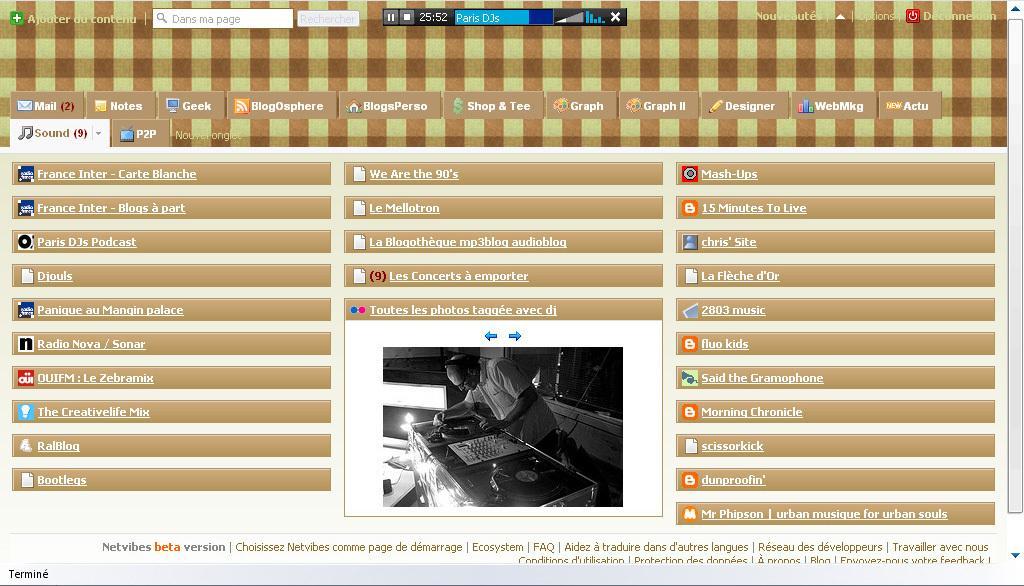In one or two sentences, can you explain what this image depicts? In this image I can see a screenshot of the screen. 